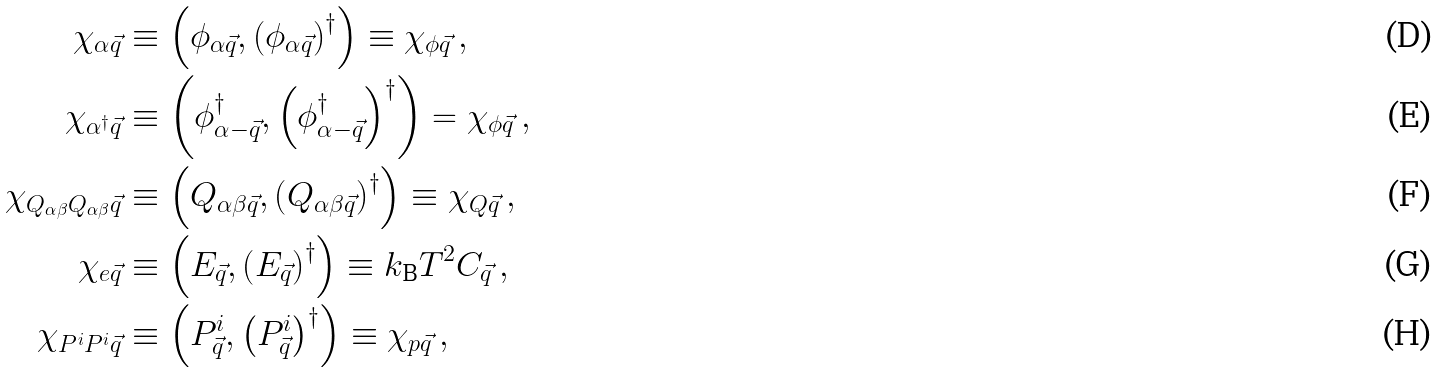<formula> <loc_0><loc_0><loc_500><loc_500>\chi _ { \alpha \vec { q } } & \equiv \left ( \phi _ { \alpha \vec { q } } , \left ( \phi _ { \alpha \vec { q } } \right ) ^ { \dagger } \right ) \equiv \chi _ { \phi \vec { q } } \, , \\ \chi _ { \alpha ^ { \dagger } \vec { q } } & \equiv \left ( \phi _ { \alpha - \vec { q } } ^ { \dagger } , \left ( \phi _ { \alpha - \vec { q } } ^ { \dagger } \right ) ^ { \dagger } \right ) = \chi _ { \phi \vec { q } } \, , \\ \chi _ { Q _ { \alpha \beta } Q _ { \alpha \beta } \vec { q } } & \equiv \left ( Q _ { \alpha \beta \vec { q } } , \left ( Q _ { \alpha \beta \vec { q } } \right ) ^ { \dagger } \right ) \equiv \chi _ { Q \vec { q } } \, , \\ \chi _ { e \vec { q } } & \equiv \left ( E _ { \vec { q } } , \left ( E _ { \vec { q } } \right ) ^ { \dagger } \right ) \equiv k _ { \text  B}T^{2}C_{\vec{q} } \, , \\ \chi _ { P ^ { i } P ^ { i } \vec { q } } & \equiv \left ( P _ { \vec { q } } ^ { i } , \left ( P _ { \vec { q } } ^ { i } \right ) ^ { \dagger } \right ) \equiv \chi _ { p \vec { q } } \, ,</formula> 